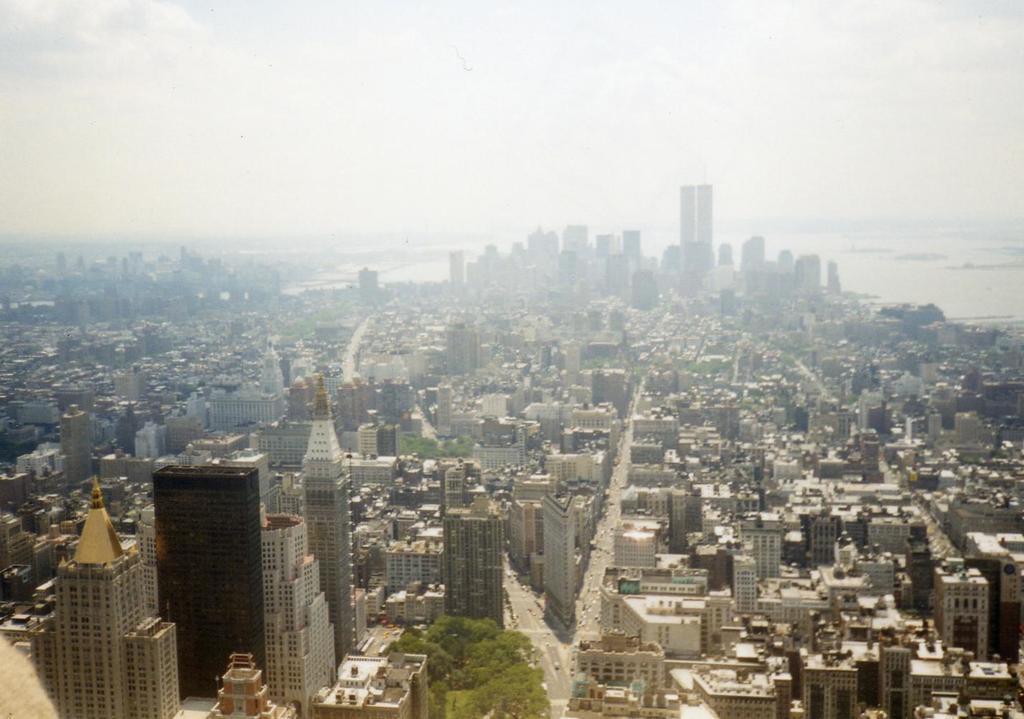Can you describe this image briefly? In this picture I can see a number of buildings. I can see a number of tower buildings. I can see trees. I can see the roads. I can see clouds in the sky. 